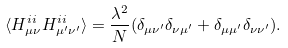<formula> <loc_0><loc_0><loc_500><loc_500>\langle H ^ { i i } _ { \mu \nu } H ^ { i i } _ { \mu ^ { \prime } \nu ^ { \prime } } \rangle = \frac { \lambda ^ { 2 } } { N } ( \delta _ { \mu \nu ^ { \prime } } \delta _ { \nu \mu ^ { \prime } } + \delta _ { \mu \mu ^ { \prime } } \delta _ { \nu \nu ^ { \prime } } ) .</formula> 